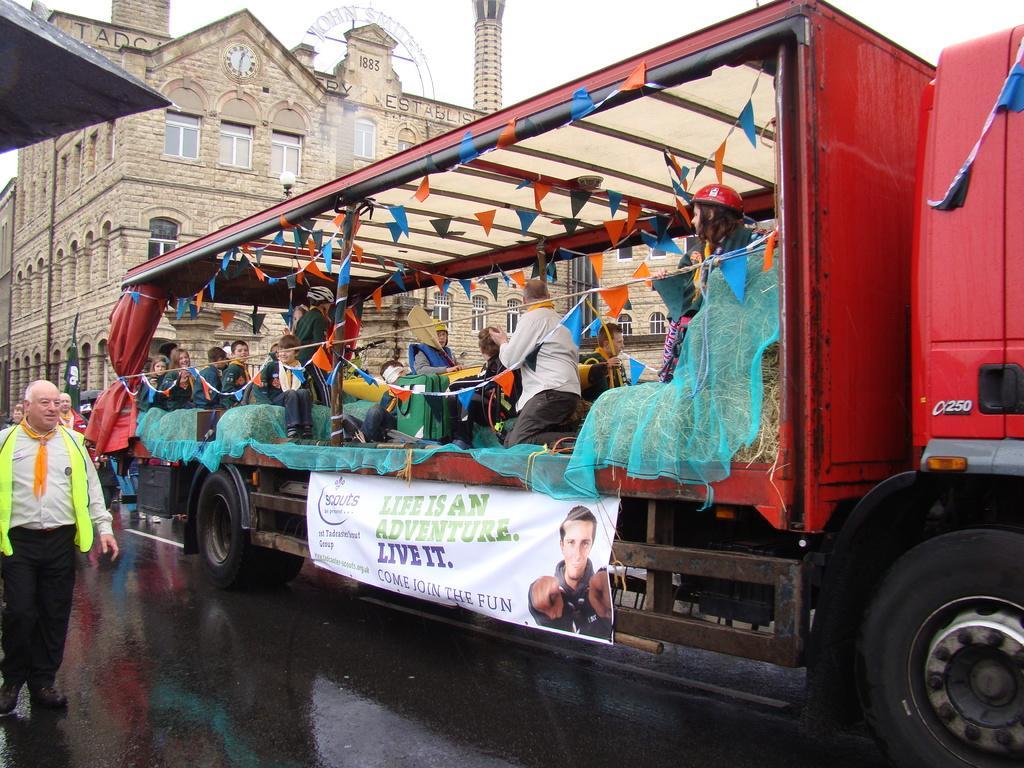Could you give a brief overview of what you see in this image? In this image I can see the road in front, on which there are few people standing and I see a vehicle, in which I see few children and other people and I can see different color of paper and I see a banner on which there is something written. In the background I can see the buildings and the sky and I can see a clock on a building. 